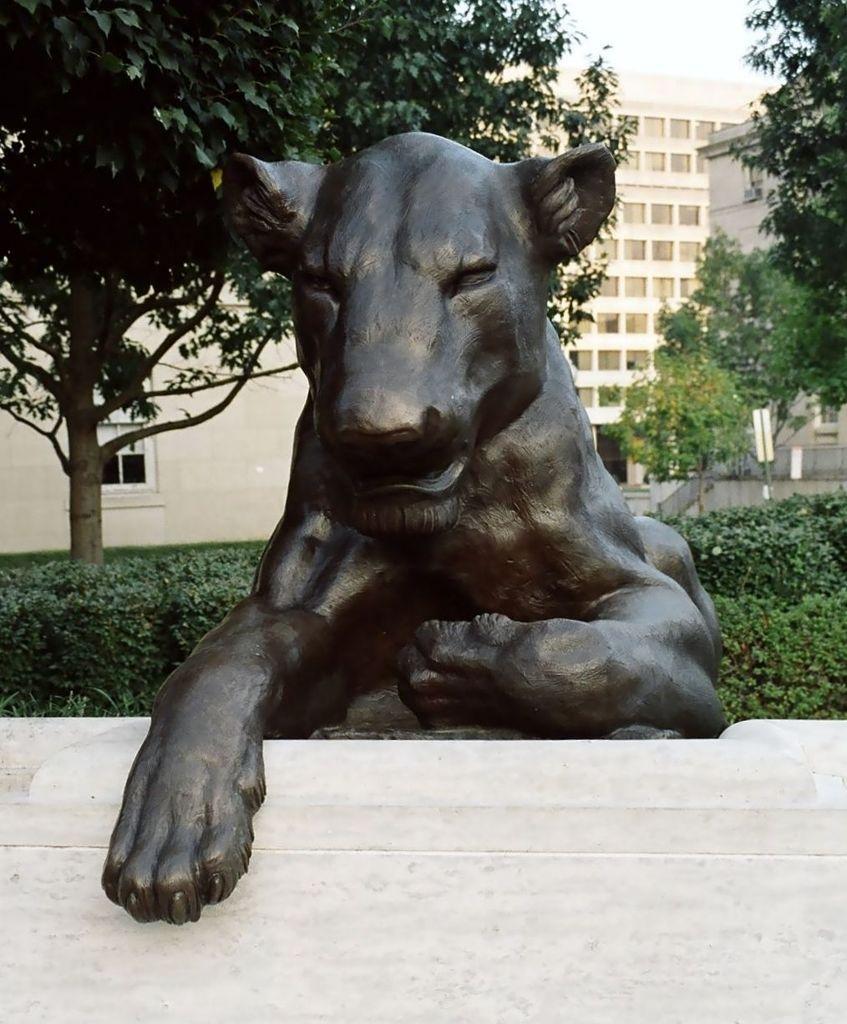Describe this image in one or two sentences. In this image I can see the black colored statue of an animal, few trees which are green in color and few buildings. In the background I can see the sky. 